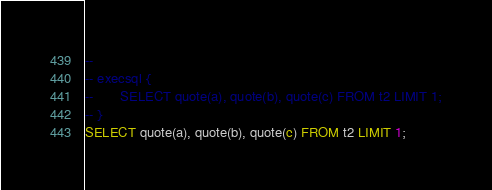<code> <loc_0><loc_0><loc_500><loc_500><_SQL_>-- 
-- execsql {
--       SELECT quote(a), quote(b), quote(c) FROM t2 LIMIT 1;
-- }
SELECT quote(a), quote(b), quote(c) FROM t2 LIMIT 1;</code> 